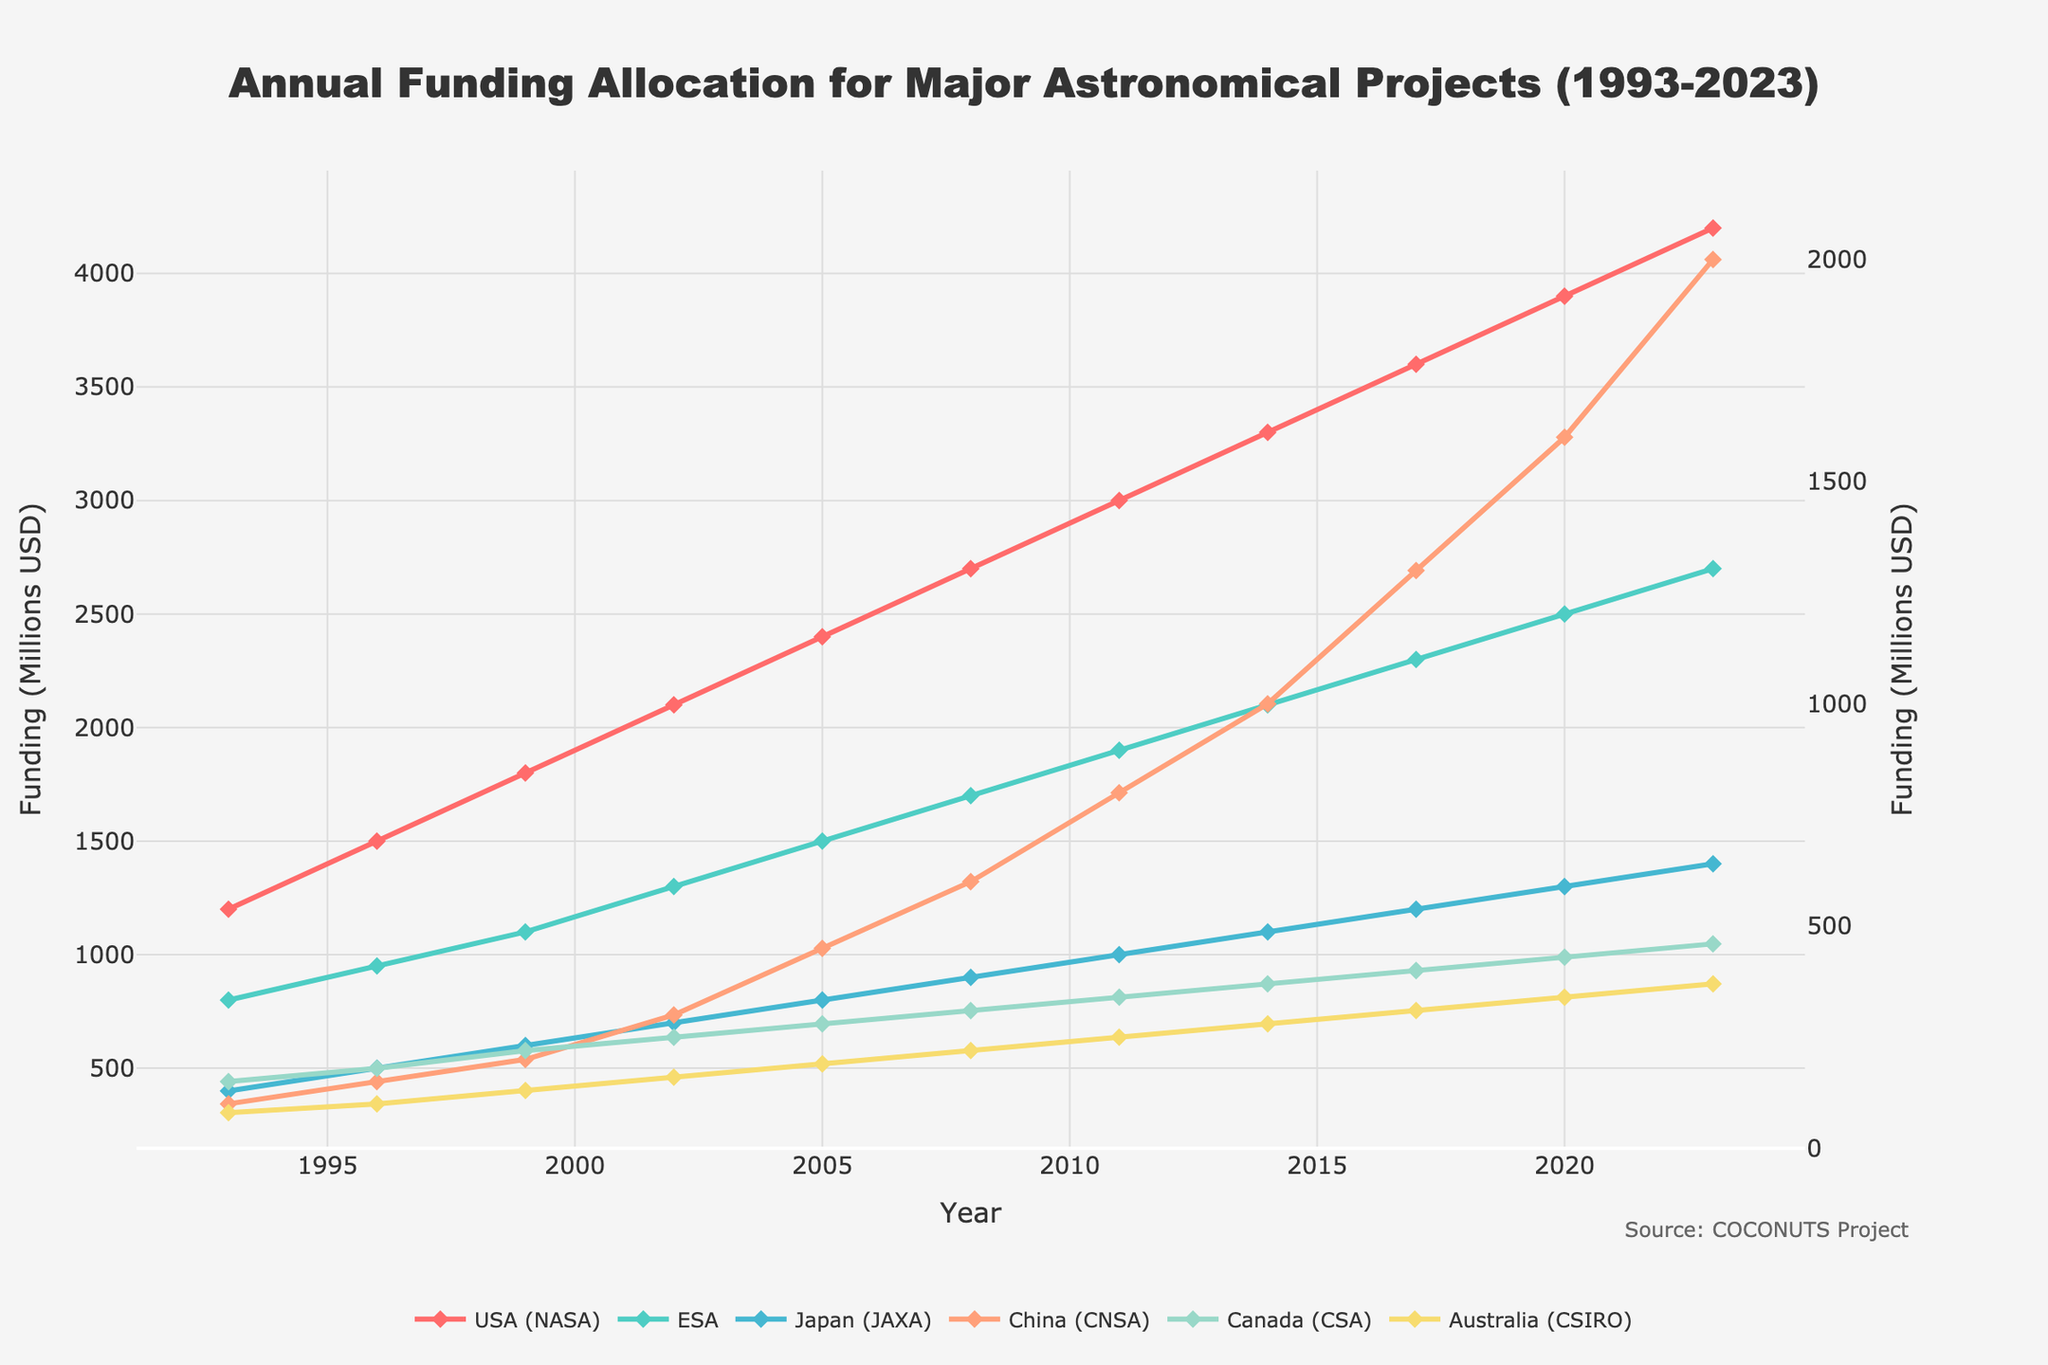what is the trend of NASA's funding from 1993 to 2023? To identify the trend of NASA's funding, we look at its funding values over the years. In 1993, it's $1200 million and it steadily increases every three years, reaching $4200 million in 2023. Therefore, the trend is an overall increase.
Answer: Increasing Which country had the highest funding in 2020? Comparing the funding allocations in 2020 for all countries, USA (NASA) had $3900 million, ESA had $2500 million, Japan (JAXA) had $1300 million, China (CNSA) had $1600 million, Canada (CSA) had $430 million, and Australia (CSIRO) had $340 million. USA (NASA) had the highest funding.
Answer: USA (NASA) How much more funding did ESA have in 2017 compared to Japan (JAXA) in the same year? In 2017, ESA had $2300 million and Japan (JAXA) had $1200 million. The difference in funding is $2300 - $1200 = $1100 million.
Answer: $1100 million Which year did China (CNSA) overtake Japan (JAXA) in funding for the first time? To determine when China overtakes Japan, we check each year's funding for both countries. In 1993 to 2014, Japan's funding was always higher. In 2017, China's funding was $1300 million, while Japan's was only $1200 million. Hence, China (CNSA) first overtook Japan (JAXA) in 2017.
Answer: 2017 What is the combined funding for Australia (CSIRO) and Canada (CSA) in 2023? Canada's funding in 2023 is $460 million, and Australia's funding is $370 million. Combined, this totals $460 + $370 = $830 million.
Answer: $830 million Compare the funding growth rates between ESA and China (CNSA) from 1993 to 2023. ESA funding in 1993 is $800 million, rising to $2700 million in 2023. This is an increase of $2700 - $800 = $1900 million. China's funding in 1993 is $100 million, increasing to $2000 million in 2023, which is a $2000 - $100 = $1900 million increase. Both ESA and China have an equal absolute growth of $1900 million over the 30-year period.
Answer: Equal absolute growth Which country's funding saw the largest percentage increase from 1993 to 2023? To calculate the largest percentage increase for each country, we use the formula ((final - initial) / initial) * 100%. 
For the USA (NASA): ((4200 - 1200) / 1200) * 100% = 250%
For ESA: ((2700 - 800) / 800) * 100% = 237.5%
For Japan (JAXA): ((1400 - 400) / 400) * 100% = 250%
For China (CNSA): ((2000 - 100) / 100) * 100% = 1900%
For Canada (CSA): ((460 - 150) / 150) * 100% = 206.67%
For Australia (CSIRO): ((370 - 80) / 80) * 100% = 362.5%
China (CNSA) had the largest percentage increase.
Answer: China (CNSA) 